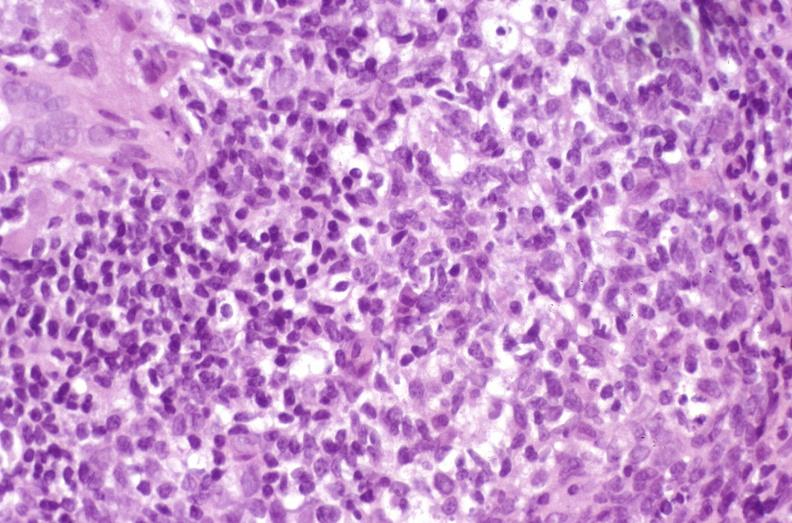s exostosis present?
Answer the question using a single word or phrase. No 